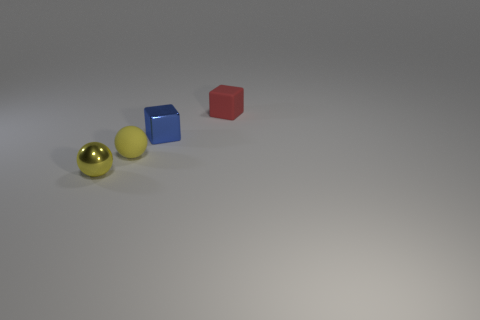Subtract all blue cubes. How many cubes are left? 1 Add 1 tiny red rubber things. How many tiny red rubber things exist? 2 Add 3 metallic balls. How many objects exist? 7 Subtract 1 blue cubes. How many objects are left? 3 Subtract 2 balls. How many balls are left? 0 Subtract all blue spheres. Subtract all purple cylinders. How many spheres are left? 2 Subtract all purple blocks. How many brown spheres are left? 0 Subtract all tiny yellow balls. Subtract all big cyan shiny spheres. How many objects are left? 2 Add 3 yellow matte spheres. How many yellow matte spheres are left? 4 